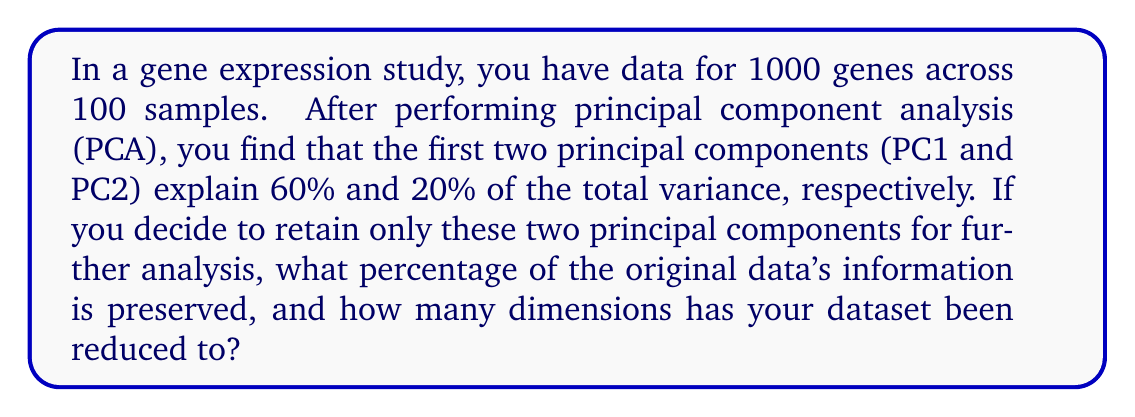What is the answer to this math problem? To solve this problem, we need to understand the concept of principal component analysis (PCA) and its application in gene expression data analysis.

1. Principal Component Analysis (PCA):
   PCA is a dimensionality reduction technique that transforms high-dimensional data into a lower-dimensional space while preserving as much variance as possible.

2. Variance explained by principal components:
   Each principal component explains a certain percentage of the total variance in the data. In this case:
   - PC1 explains 60% of the variance
   - PC2 explains 20% of the variance

3. Calculating the total preserved information:
   To find the percentage of original data's information preserved, we sum the variance explained by the retained principal components:
   
   $$ \text{Preserved Information} = \text{Variance}_{\text{PC1}} + \text{Variance}_{\text{PC2}} $$
   $$ \text{Preserved Information} = 60\% + 20\% = 80\% $$

4. Dimensionality reduction:
   - Original dimensions: 1000 genes (features)
   - Retained dimensions: 2 principal components

   The dataset has been reduced from 1000 dimensions to 2 dimensions.

5. Final result:
   By retaining only the first two principal components, we preserve 80% of the original data's information while reducing the dataset from 1000 dimensions to 2 dimensions.
Answer: 80% of the original data's information is preserved, and the dataset has been reduced from 1000 dimensions to 2 dimensions. 